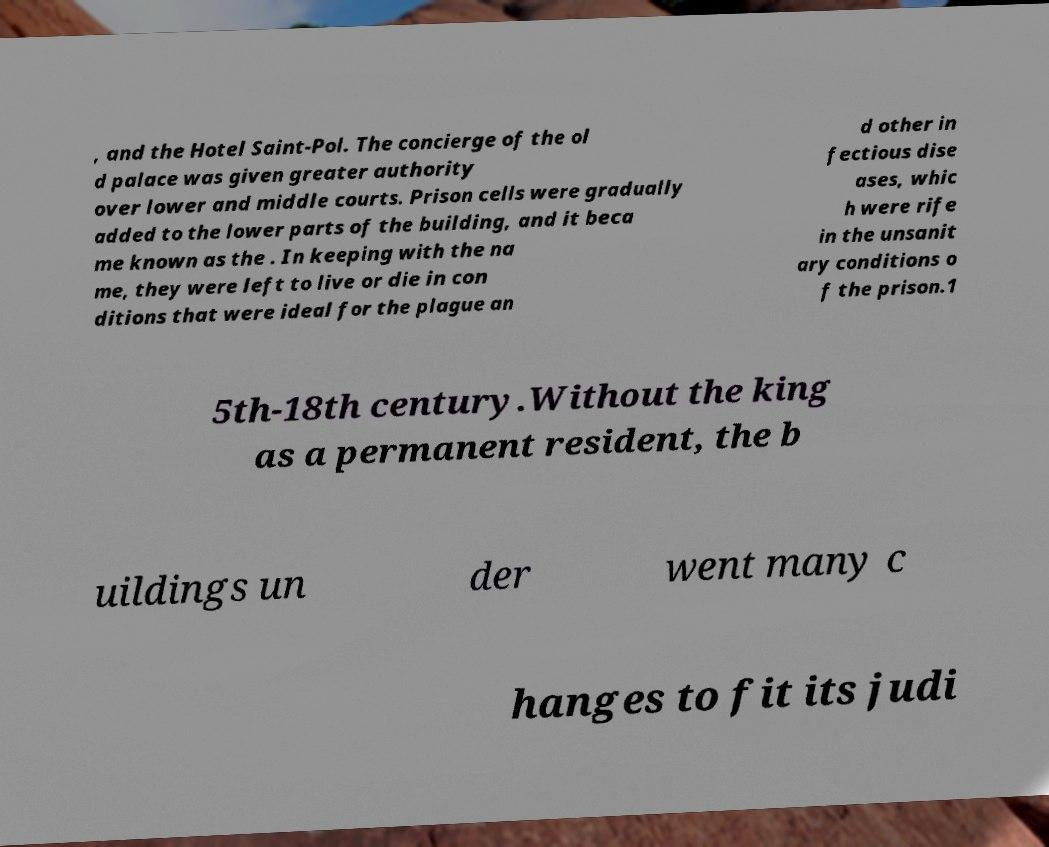For documentation purposes, I need the text within this image transcribed. Could you provide that? , and the Hotel Saint-Pol. The concierge of the ol d palace was given greater authority over lower and middle courts. Prison cells were gradually added to the lower parts of the building, and it beca me known as the . In keeping with the na me, they were left to live or die in con ditions that were ideal for the plague an d other in fectious dise ases, whic h were rife in the unsanit ary conditions o f the prison.1 5th-18th century.Without the king as a permanent resident, the b uildings un der went many c hanges to fit its judi 